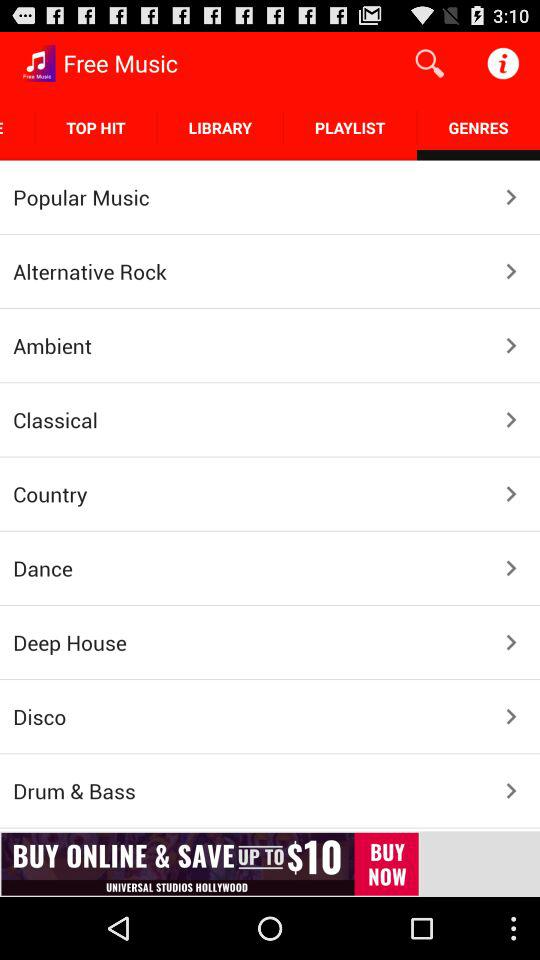What is the application name? The application name is "Free Music". 